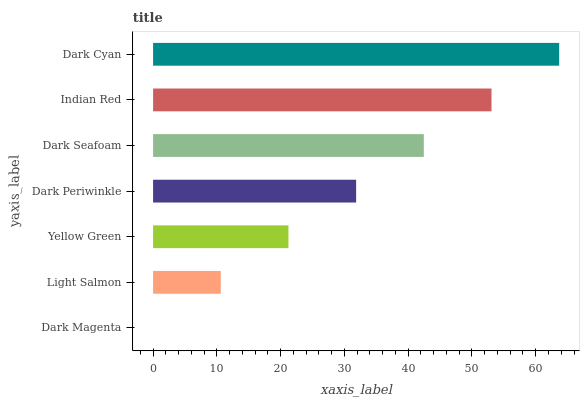Is Dark Magenta the minimum?
Answer yes or no. Yes. Is Dark Cyan the maximum?
Answer yes or no. Yes. Is Light Salmon the minimum?
Answer yes or no. No. Is Light Salmon the maximum?
Answer yes or no. No. Is Light Salmon greater than Dark Magenta?
Answer yes or no. Yes. Is Dark Magenta less than Light Salmon?
Answer yes or no. Yes. Is Dark Magenta greater than Light Salmon?
Answer yes or no. No. Is Light Salmon less than Dark Magenta?
Answer yes or no. No. Is Dark Periwinkle the high median?
Answer yes or no. Yes. Is Dark Periwinkle the low median?
Answer yes or no. Yes. Is Dark Seafoam the high median?
Answer yes or no. No. Is Dark Magenta the low median?
Answer yes or no. No. 